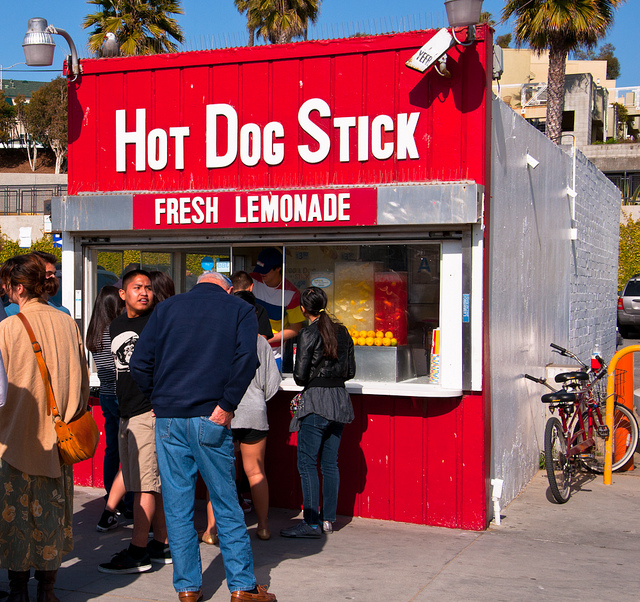Read all the text in this image. HOT Doc STICK FRESH LEMONADE A YEFB 